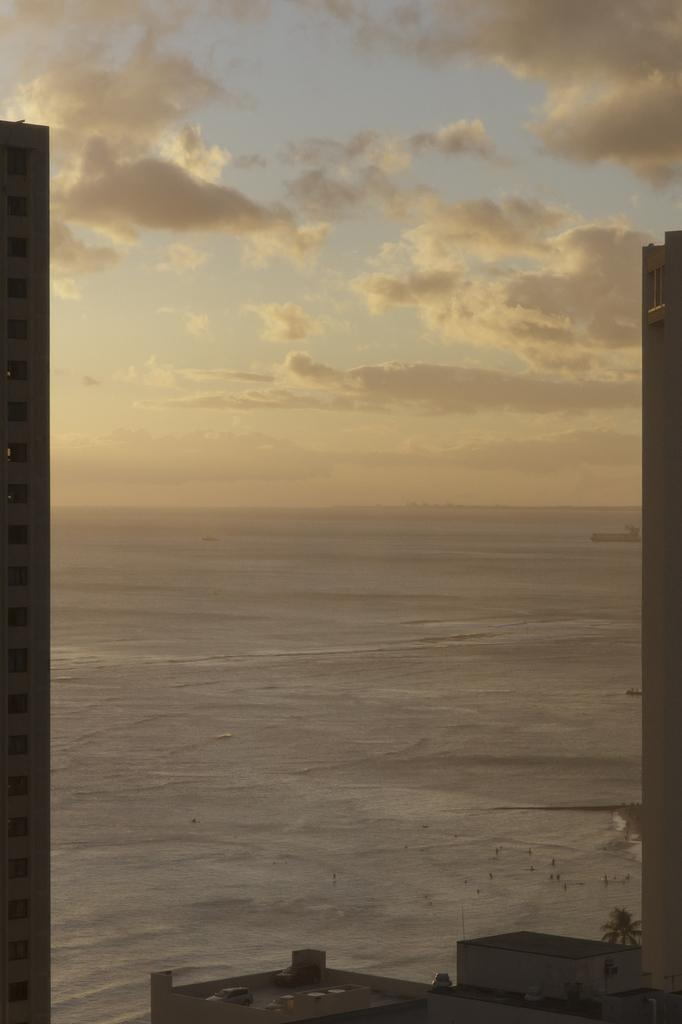What type of structures can be seen in the image? There are buildings in the image. What type of vegetation is present in the image? There are trees in the image. What natural element is visible in the image? There is water visible in the image. What can be seen in the sky in the image? There are clouds in the image. What time of day is it in the image, and can you see the morning sun? The time of day is not specified in the image, and there is no mention of a morning sun. What type of nose can be seen on the buildings in the image? There are no noses present on the buildings in the image. 